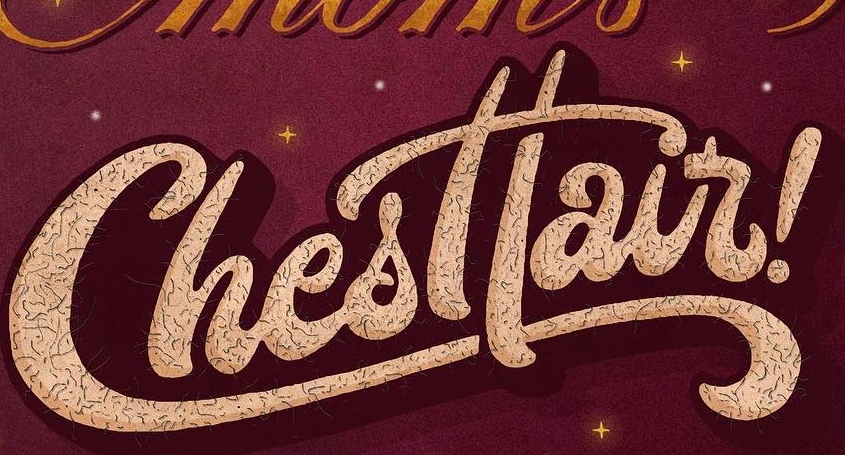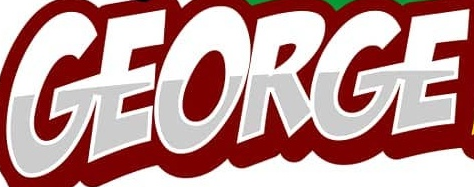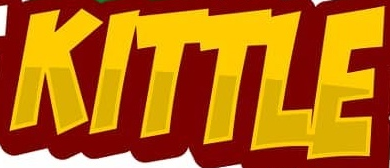What words can you see in these images in sequence, separated by a semicolon? Chesttair; GEORGE; KITTLE 